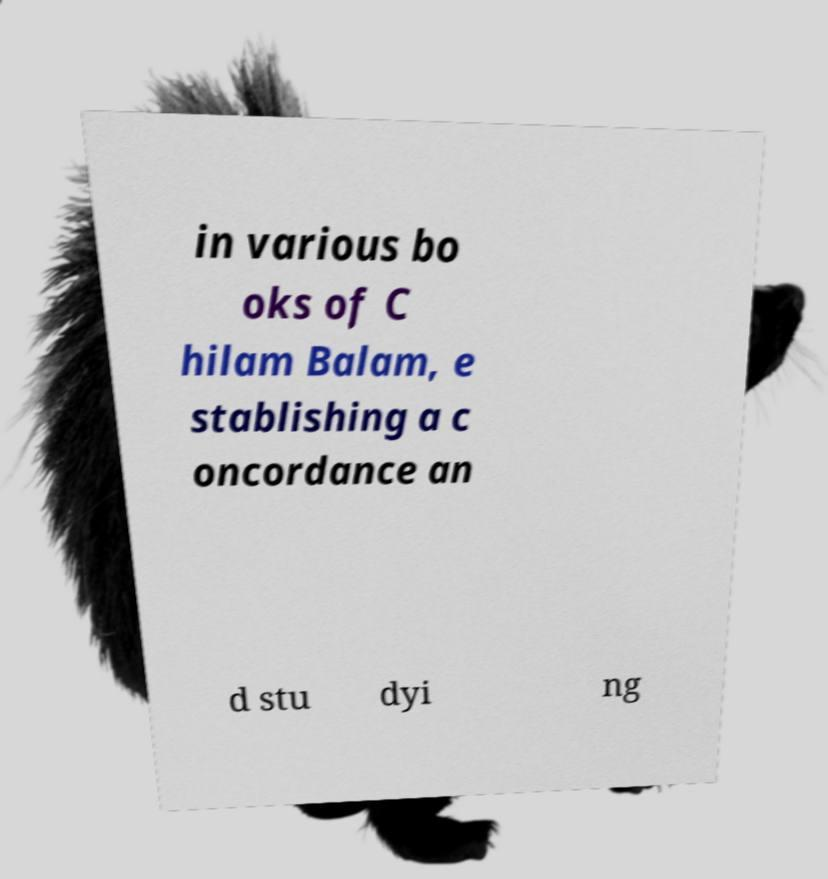Can you read and provide the text displayed in the image?This photo seems to have some interesting text. Can you extract and type it out for me? in various bo oks of C hilam Balam, e stablishing a c oncordance an d stu dyi ng 